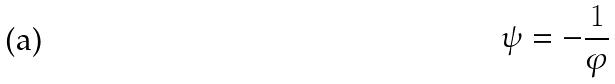Convert formula to latex. <formula><loc_0><loc_0><loc_500><loc_500>\psi = - \frac { 1 } { \varphi }</formula> 